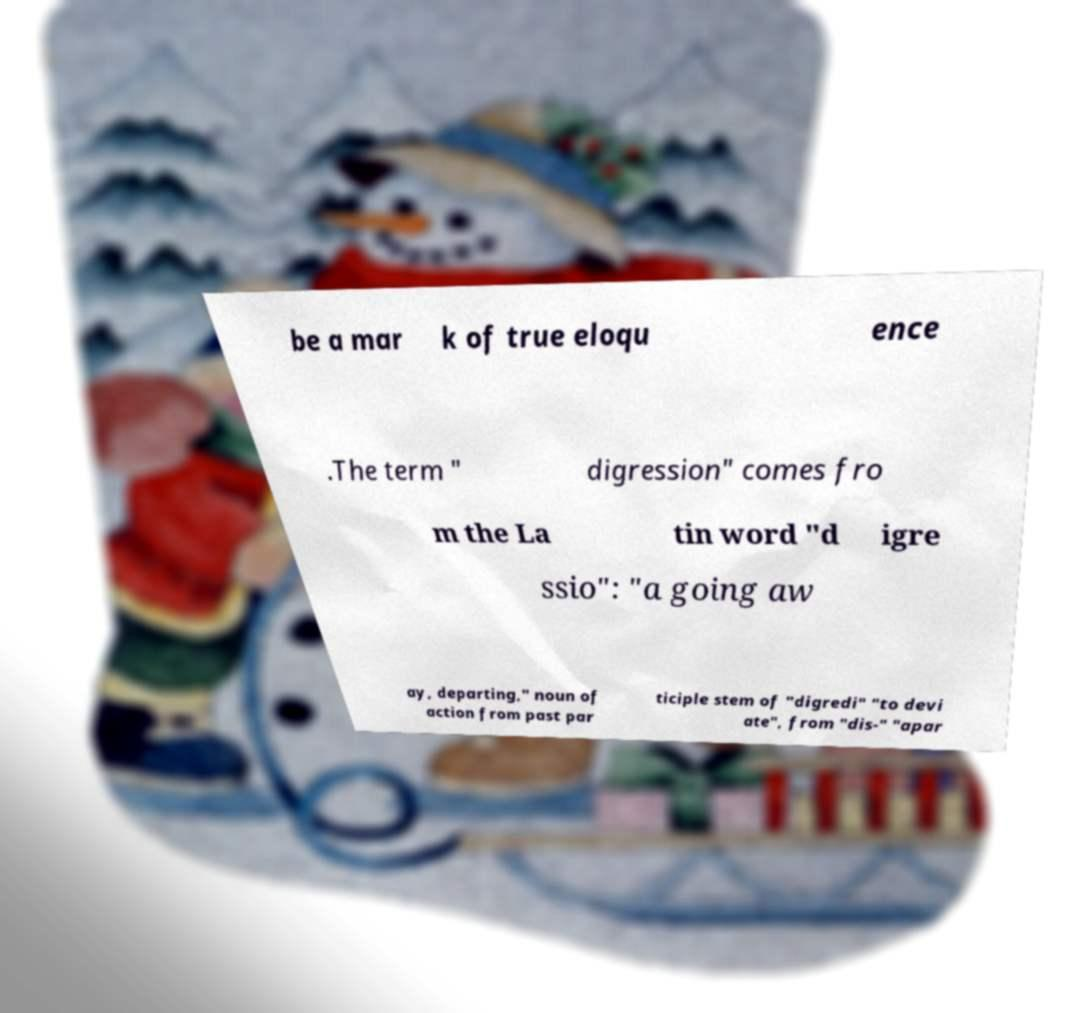Could you extract and type out the text from this image? be a mar k of true eloqu ence .The term " digression" comes fro m the La tin word "d igre ssio": "a going aw ay, departing," noun of action from past par ticiple stem of "digredi" "to devi ate", from "dis-" "apar 